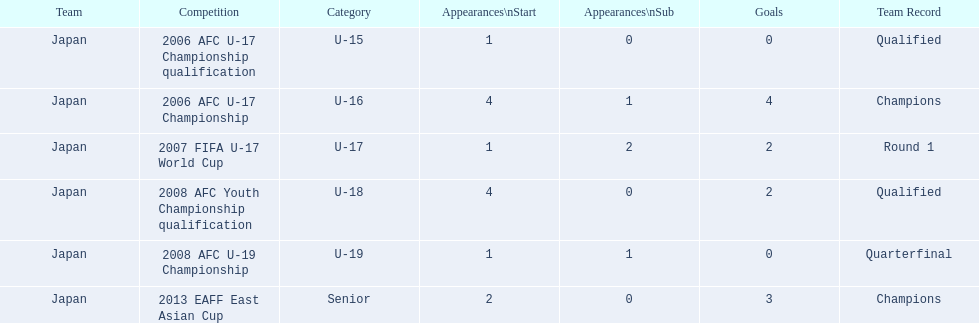In what tournaments did japan engage in with yoichiro kakitani? 2006 AFC U-17 Championship qualification, 2006 AFC U-17 Championship, 2007 FIFA U-17 World Cup, 2008 AFC Youth Championship qualification, 2008 AFC U-19 Championship, 2013 EAFF East Asian Cup. From those tournaments, which were conducted in 2007 and 2013? 2007 FIFA U-17 World Cup, 2013 EAFF East Asian Cup. Among the 2007 fifa u-17 world cup and the 2013 eaff east asian cup, where did japan have the greatest number of starting appearances? 2013 EAFF East Asian Cup. Which tournaments featured record-breaking champion teams? 2006 AFC U-17 Championship, 2013 EAFF East Asian Cup. Out of these, which one was part of the senior division? 2013 EAFF East Asian Cup. 